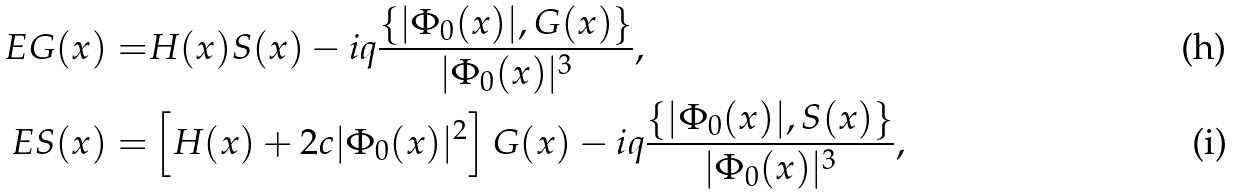Convert formula to latex. <formula><loc_0><loc_0><loc_500><loc_500>E G ( x ) = & H ( x ) S ( x ) - i q \frac { \left \{ | \Phi _ { 0 } ( x ) | , G ( x ) \right \} } { | \Phi _ { 0 } ( x ) | ^ { 3 } } , \\ E S ( x ) = & \left [ H ( x ) + 2 c | \Phi _ { 0 } ( x ) | ^ { 2 } \right ] G ( x ) - i q \frac { \left \{ | \Phi _ { 0 } ( x ) | , S ( x ) \right \} } { | \Phi _ { 0 } ( x ) | ^ { 3 } } ,</formula> 